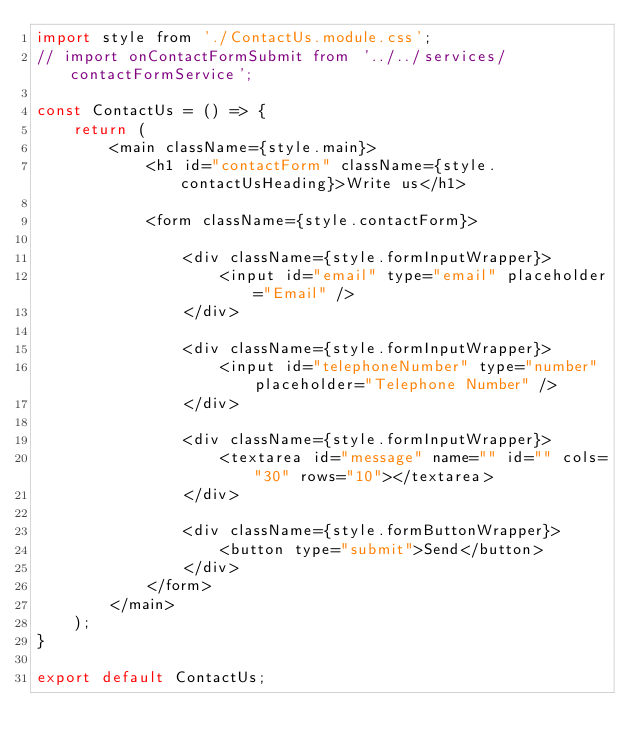<code> <loc_0><loc_0><loc_500><loc_500><_JavaScript_>import style from './ContactUs.module.css';
// import onContactFormSubmit from '../../services/contactFormService';

const ContactUs = () => {
    return (
        <main className={style.main}>
            <h1 id="contactForm" className={style.contactUsHeading}>Write us</h1>

            <form className={style.contactForm}>

                <div className={style.formInputWrapper}>
                    <input id="email" type="email" placeholder="Email" />
                </div>

                <div className={style.formInputWrapper}>
                    <input id="telephoneNumber" type="number" placeholder="Telephone Number" />
                </div>

                <div className={style.formInputWrapper}>
                    <textarea id="message" name="" id="" cols="30" rows="10"></textarea>
                </div>

                <div className={style.formButtonWrapper}>
                    <button type="submit">Send</button>
                </div>
            </form>
        </main>
    );
}

export default ContactUs;</code> 